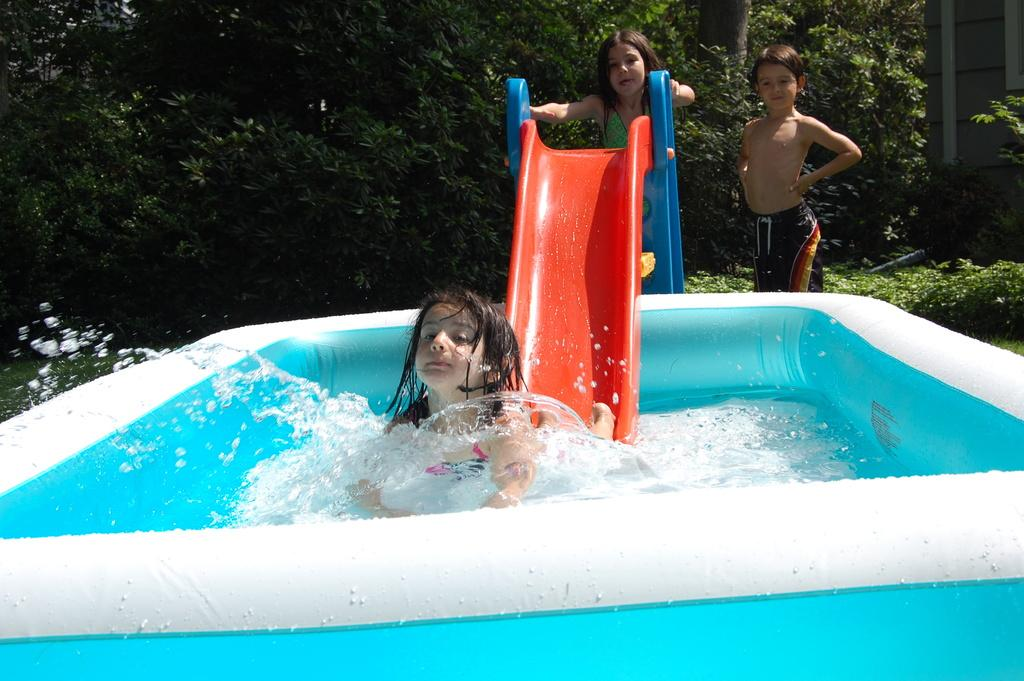What is present in the image that is not solid? There is water in the image. What type of playground equipment can be seen in the image? There is a slide in the image. Who is present in the image? There are children in the image. Can you describe the girl's location in the image? One girl is in the water. What can be seen in the background of the image? There are plants and trees in the background of the image. What type of meat is being cooked by the children in the image? There is no meat or cooking activity present in the image. What type of suit is the girl wearing in the water? The girl is not wearing a suit in the water; she is in a swimsuit or regular clothing. 